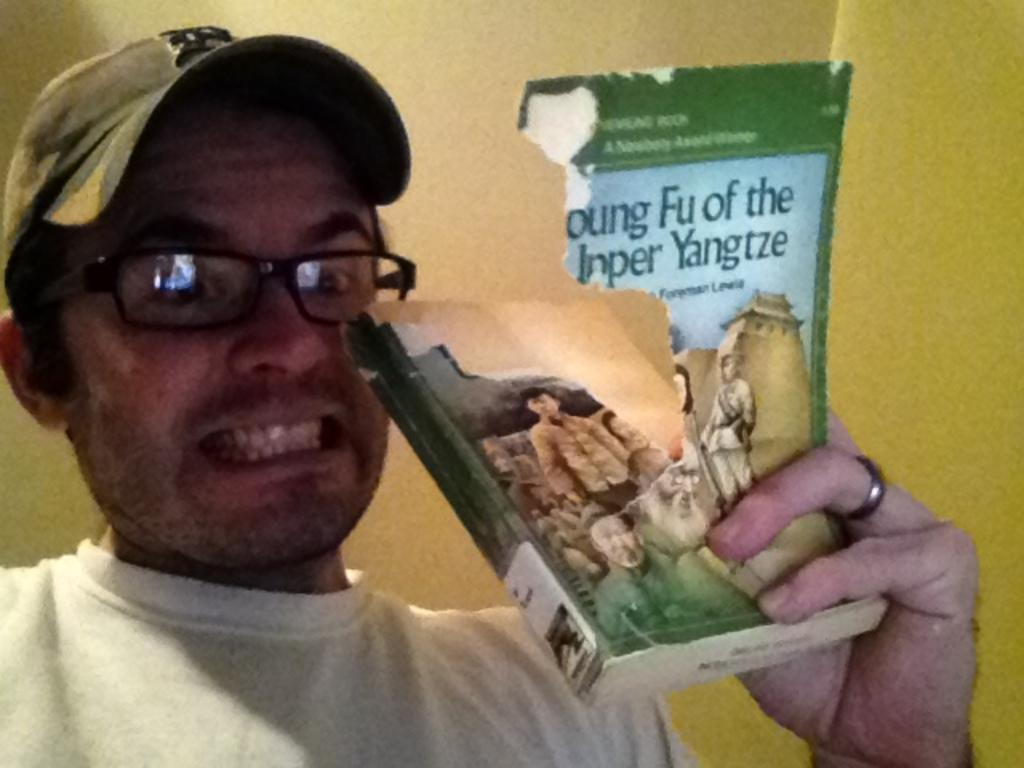What is the person in the image doing? The person in the image is holding a book. Can you describe the condition of the book? The book is torn. What can be seen in the background of the image? There is a wall in the background of the image. How does the person in the image apply the brake while holding the book? There is no mention of a vehicle or brake in the image, so it is not applicable to the situation. 